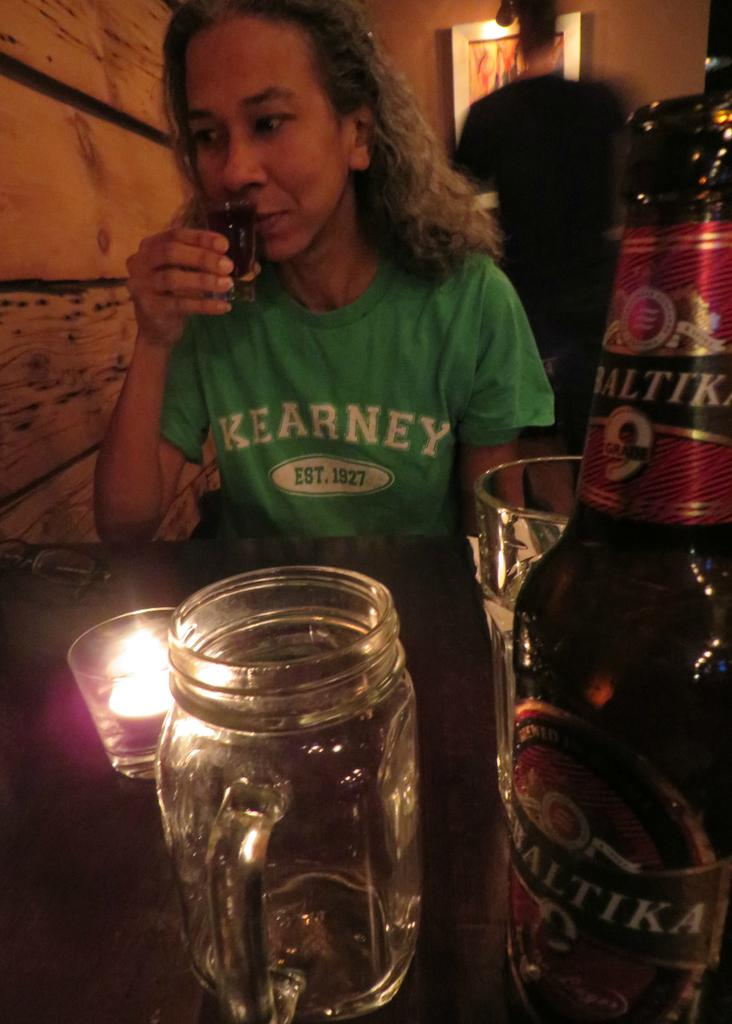Provide a one-sentence caption for the provided image. a woman wearing a green shirt that says 'kearney est. 1927' on it. 